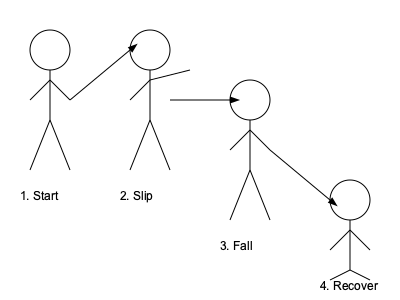In the illustrated slapstick routine, what is the correct sequence of movements to maximize comedic effect while ensuring a safe performance? To choreograph an effective and safe slapstick routine, follow these steps:

1. Start: Begin in a neutral standing position, as shown in the first stick figure. This establishes the character's initial state and builds anticipation.

2. Slip: Initiate the comedic action by simulating a slip. The second stick figure demonstrates this with an outstretched arm for balance and a leg lifting off the ground. This sudden change in posture creates the first laugh.

3. Fall: Progress to a full fall, as depicted in the third stick figure. The body is shown at an angle, with arms and legs flailing. This is the climax of the physical comedy, eliciting the biggest laugh.

4. Recover: Finish with a recovery, as illustrated in the fourth stick figure. The character is shown getting up, potentially with exaggerated movements. This provides closure to the routine and sets up for the next gag.

Key points to remember:
- Exaggerate movements for visual impact
- Maintain control throughout the routine to ensure safety
- Practice timing to maximize comedic effect
- Use facial expressions (not shown in stick figures) to enhance the performance

By following this sequence, you create a classic slapstick routine that builds from anticipation to climax, ending with a recovery that leaves the audience ready for more.
Answer: Start, slip, fall, recover 